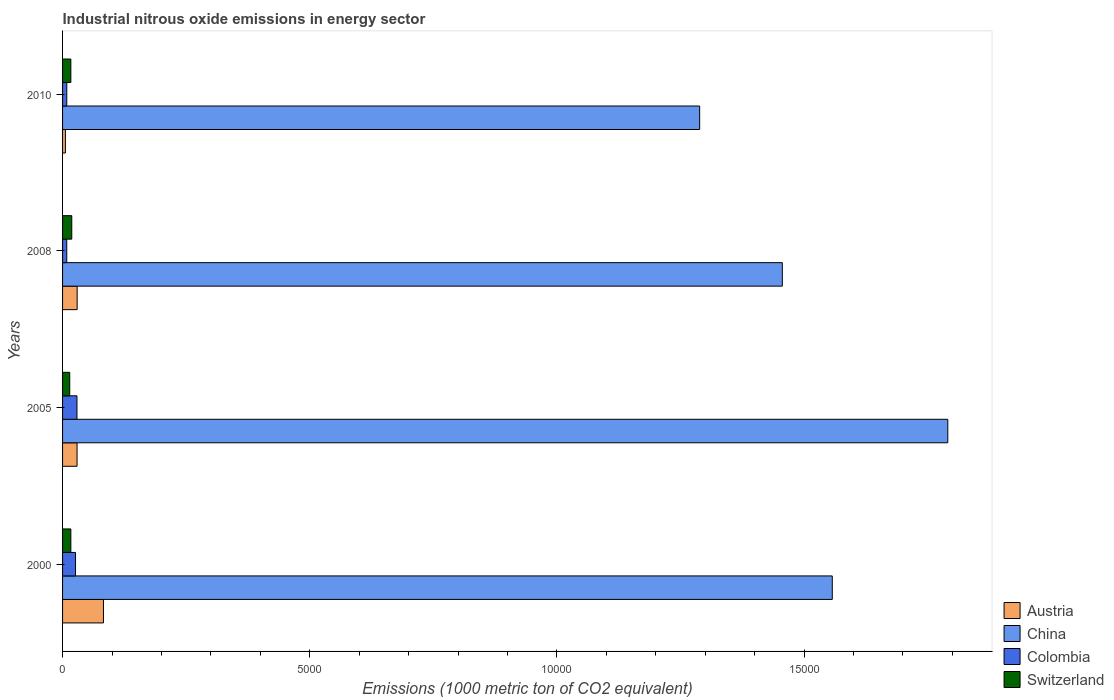How many different coloured bars are there?
Offer a terse response. 4. In how many cases, is the number of bars for a given year not equal to the number of legend labels?
Keep it short and to the point. 0. What is the amount of industrial nitrous oxide emitted in Colombia in 2008?
Your response must be concise. 84.7. Across all years, what is the maximum amount of industrial nitrous oxide emitted in Austria?
Provide a succinct answer. 827.2. Across all years, what is the minimum amount of industrial nitrous oxide emitted in China?
Offer a very short reply. 1.29e+04. In which year was the amount of industrial nitrous oxide emitted in China minimum?
Make the answer very short. 2010. What is the total amount of industrial nitrous oxide emitted in Austria in the graph?
Make the answer very short. 1473.2. What is the difference between the amount of industrial nitrous oxide emitted in China in 2000 and that in 2010?
Your answer should be very brief. 2682.7. What is the difference between the amount of industrial nitrous oxide emitted in Switzerland in 2005 and the amount of industrial nitrous oxide emitted in Colombia in 2000?
Your answer should be very brief. -117.2. What is the average amount of industrial nitrous oxide emitted in China per year?
Make the answer very short. 1.52e+04. In the year 2008, what is the difference between the amount of industrial nitrous oxide emitted in Austria and amount of industrial nitrous oxide emitted in China?
Your answer should be very brief. -1.43e+04. What is the ratio of the amount of industrial nitrous oxide emitted in China in 2000 to that in 2008?
Your answer should be compact. 1.07. Is the amount of industrial nitrous oxide emitted in Austria in 2005 less than that in 2008?
Your answer should be very brief. Yes. What is the difference between the highest and the second highest amount of industrial nitrous oxide emitted in Switzerland?
Your answer should be very brief. 18.6. What is the difference between the highest and the lowest amount of industrial nitrous oxide emitted in Austria?
Your answer should be very brief. 769.7. In how many years, is the amount of industrial nitrous oxide emitted in China greater than the average amount of industrial nitrous oxide emitted in China taken over all years?
Offer a terse response. 2. Is the sum of the amount of industrial nitrous oxide emitted in Colombia in 2005 and 2010 greater than the maximum amount of industrial nitrous oxide emitted in Austria across all years?
Provide a succinct answer. No. What does the 2nd bar from the top in 2010 represents?
Your answer should be very brief. Colombia. What does the 4th bar from the bottom in 2008 represents?
Provide a short and direct response. Switzerland. How many bars are there?
Your answer should be very brief. 16. Are all the bars in the graph horizontal?
Your answer should be compact. Yes. How many years are there in the graph?
Keep it short and to the point. 4. Does the graph contain grids?
Ensure brevity in your answer.  No. Where does the legend appear in the graph?
Provide a succinct answer. Bottom right. What is the title of the graph?
Your answer should be compact. Industrial nitrous oxide emissions in energy sector. Does "Middle East & North Africa (developing only)" appear as one of the legend labels in the graph?
Your answer should be very brief. No. What is the label or title of the X-axis?
Provide a short and direct response. Emissions (1000 metric ton of CO2 equivalent). What is the Emissions (1000 metric ton of CO2 equivalent) of Austria in 2000?
Your answer should be very brief. 827.2. What is the Emissions (1000 metric ton of CO2 equivalent) in China in 2000?
Offer a very short reply. 1.56e+04. What is the Emissions (1000 metric ton of CO2 equivalent) of Colombia in 2000?
Provide a short and direct response. 262.3. What is the Emissions (1000 metric ton of CO2 equivalent) in Switzerland in 2000?
Make the answer very short. 167.4. What is the Emissions (1000 metric ton of CO2 equivalent) of Austria in 2005?
Keep it short and to the point. 293.3. What is the Emissions (1000 metric ton of CO2 equivalent) in China in 2005?
Make the answer very short. 1.79e+04. What is the Emissions (1000 metric ton of CO2 equivalent) in Colombia in 2005?
Your response must be concise. 291.3. What is the Emissions (1000 metric ton of CO2 equivalent) of Switzerland in 2005?
Offer a very short reply. 145.1. What is the Emissions (1000 metric ton of CO2 equivalent) in Austria in 2008?
Offer a terse response. 295.2. What is the Emissions (1000 metric ton of CO2 equivalent) in China in 2008?
Keep it short and to the point. 1.46e+04. What is the Emissions (1000 metric ton of CO2 equivalent) in Colombia in 2008?
Your answer should be compact. 84.7. What is the Emissions (1000 metric ton of CO2 equivalent) in Switzerland in 2008?
Give a very brief answer. 186. What is the Emissions (1000 metric ton of CO2 equivalent) in Austria in 2010?
Offer a very short reply. 57.5. What is the Emissions (1000 metric ton of CO2 equivalent) of China in 2010?
Provide a short and direct response. 1.29e+04. What is the Emissions (1000 metric ton of CO2 equivalent) in Colombia in 2010?
Ensure brevity in your answer.  85.2. What is the Emissions (1000 metric ton of CO2 equivalent) in Switzerland in 2010?
Offer a terse response. 167.4. Across all years, what is the maximum Emissions (1000 metric ton of CO2 equivalent) in Austria?
Your answer should be compact. 827.2. Across all years, what is the maximum Emissions (1000 metric ton of CO2 equivalent) in China?
Offer a terse response. 1.79e+04. Across all years, what is the maximum Emissions (1000 metric ton of CO2 equivalent) of Colombia?
Give a very brief answer. 291.3. Across all years, what is the maximum Emissions (1000 metric ton of CO2 equivalent) in Switzerland?
Make the answer very short. 186. Across all years, what is the minimum Emissions (1000 metric ton of CO2 equivalent) of Austria?
Ensure brevity in your answer.  57.5. Across all years, what is the minimum Emissions (1000 metric ton of CO2 equivalent) of China?
Make the answer very short. 1.29e+04. Across all years, what is the minimum Emissions (1000 metric ton of CO2 equivalent) of Colombia?
Your answer should be compact. 84.7. Across all years, what is the minimum Emissions (1000 metric ton of CO2 equivalent) of Switzerland?
Make the answer very short. 145.1. What is the total Emissions (1000 metric ton of CO2 equivalent) of Austria in the graph?
Ensure brevity in your answer.  1473.2. What is the total Emissions (1000 metric ton of CO2 equivalent) of China in the graph?
Provide a short and direct response. 6.09e+04. What is the total Emissions (1000 metric ton of CO2 equivalent) in Colombia in the graph?
Make the answer very short. 723.5. What is the total Emissions (1000 metric ton of CO2 equivalent) of Switzerland in the graph?
Keep it short and to the point. 665.9. What is the difference between the Emissions (1000 metric ton of CO2 equivalent) in Austria in 2000 and that in 2005?
Offer a very short reply. 533.9. What is the difference between the Emissions (1000 metric ton of CO2 equivalent) of China in 2000 and that in 2005?
Offer a very short reply. -2336.7. What is the difference between the Emissions (1000 metric ton of CO2 equivalent) of Switzerland in 2000 and that in 2005?
Offer a very short reply. 22.3. What is the difference between the Emissions (1000 metric ton of CO2 equivalent) in Austria in 2000 and that in 2008?
Keep it short and to the point. 532. What is the difference between the Emissions (1000 metric ton of CO2 equivalent) in China in 2000 and that in 2008?
Your response must be concise. 1010.8. What is the difference between the Emissions (1000 metric ton of CO2 equivalent) of Colombia in 2000 and that in 2008?
Keep it short and to the point. 177.6. What is the difference between the Emissions (1000 metric ton of CO2 equivalent) of Switzerland in 2000 and that in 2008?
Your answer should be compact. -18.6. What is the difference between the Emissions (1000 metric ton of CO2 equivalent) of Austria in 2000 and that in 2010?
Give a very brief answer. 769.7. What is the difference between the Emissions (1000 metric ton of CO2 equivalent) of China in 2000 and that in 2010?
Make the answer very short. 2682.7. What is the difference between the Emissions (1000 metric ton of CO2 equivalent) of Colombia in 2000 and that in 2010?
Make the answer very short. 177.1. What is the difference between the Emissions (1000 metric ton of CO2 equivalent) in Austria in 2005 and that in 2008?
Your answer should be very brief. -1.9. What is the difference between the Emissions (1000 metric ton of CO2 equivalent) in China in 2005 and that in 2008?
Make the answer very short. 3347.5. What is the difference between the Emissions (1000 metric ton of CO2 equivalent) of Colombia in 2005 and that in 2008?
Keep it short and to the point. 206.6. What is the difference between the Emissions (1000 metric ton of CO2 equivalent) in Switzerland in 2005 and that in 2008?
Your response must be concise. -40.9. What is the difference between the Emissions (1000 metric ton of CO2 equivalent) of Austria in 2005 and that in 2010?
Give a very brief answer. 235.8. What is the difference between the Emissions (1000 metric ton of CO2 equivalent) of China in 2005 and that in 2010?
Offer a terse response. 5019.4. What is the difference between the Emissions (1000 metric ton of CO2 equivalent) of Colombia in 2005 and that in 2010?
Offer a terse response. 206.1. What is the difference between the Emissions (1000 metric ton of CO2 equivalent) in Switzerland in 2005 and that in 2010?
Make the answer very short. -22.3. What is the difference between the Emissions (1000 metric ton of CO2 equivalent) in Austria in 2008 and that in 2010?
Your response must be concise. 237.7. What is the difference between the Emissions (1000 metric ton of CO2 equivalent) in China in 2008 and that in 2010?
Offer a terse response. 1671.9. What is the difference between the Emissions (1000 metric ton of CO2 equivalent) in Colombia in 2008 and that in 2010?
Your response must be concise. -0.5. What is the difference between the Emissions (1000 metric ton of CO2 equivalent) of Austria in 2000 and the Emissions (1000 metric ton of CO2 equivalent) of China in 2005?
Give a very brief answer. -1.71e+04. What is the difference between the Emissions (1000 metric ton of CO2 equivalent) of Austria in 2000 and the Emissions (1000 metric ton of CO2 equivalent) of Colombia in 2005?
Your answer should be compact. 535.9. What is the difference between the Emissions (1000 metric ton of CO2 equivalent) in Austria in 2000 and the Emissions (1000 metric ton of CO2 equivalent) in Switzerland in 2005?
Your answer should be compact. 682.1. What is the difference between the Emissions (1000 metric ton of CO2 equivalent) of China in 2000 and the Emissions (1000 metric ton of CO2 equivalent) of Colombia in 2005?
Ensure brevity in your answer.  1.53e+04. What is the difference between the Emissions (1000 metric ton of CO2 equivalent) of China in 2000 and the Emissions (1000 metric ton of CO2 equivalent) of Switzerland in 2005?
Provide a short and direct response. 1.54e+04. What is the difference between the Emissions (1000 metric ton of CO2 equivalent) in Colombia in 2000 and the Emissions (1000 metric ton of CO2 equivalent) in Switzerland in 2005?
Give a very brief answer. 117.2. What is the difference between the Emissions (1000 metric ton of CO2 equivalent) in Austria in 2000 and the Emissions (1000 metric ton of CO2 equivalent) in China in 2008?
Your answer should be very brief. -1.37e+04. What is the difference between the Emissions (1000 metric ton of CO2 equivalent) of Austria in 2000 and the Emissions (1000 metric ton of CO2 equivalent) of Colombia in 2008?
Provide a short and direct response. 742.5. What is the difference between the Emissions (1000 metric ton of CO2 equivalent) of Austria in 2000 and the Emissions (1000 metric ton of CO2 equivalent) of Switzerland in 2008?
Your response must be concise. 641.2. What is the difference between the Emissions (1000 metric ton of CO2 equivalent) of China in 2000 and the Emissions (1000 metric ton of CO2 equivalent) of Colombia in 2008?
Give a very brief answer. 1.55e+04. What is the difference between the Emissions (1000 metric ton of CO2 equivalent) in China in 2000 and the Emissions (1000 metric ton of CO2 equivalent) in Switzerland in 2008?
Your response must be concise. 1.54e+04. What is the difference between the Emissions (1000 metric ton of CO2 equivalent) in Colombia in 2000 and the Emissions (1000 metric ton of CO2 equivalent) in Switzerland in 2008?
Ensure brevity in your answer.  76.3. What is the difference between the Emissions (1000 metric ton of CO2 equivalent) of Austria in 2000 and the Emissions (1000 metric ton of CO2 equivalent) of China in 2010?
Provide a short and direct response. -1.21e+04. What is the difference between the Emissions (1000 metric ton of CO2 equivalent) in Austria in 2000 and the Emissions (1000 metric ton of CO2 equivalent) in Colombia in 2010?
Your answer should be compact. 742. What is the difference between the Emissions (1000 metric ton of CO2 equivalent) of Austria in 2000 and the Emissions (1000 metric ton of CO2 equivalent) of Switzerland in 2010?
Your answer should be compact. 659.8. What is the difference between the Emissions (1000 metric ton of CO2 equivalent) of China in 2000 and the Emissions (1000 metric ton of CO2 equivalent) of Colombia in 2010?
Offer a terse response. 1.55e+04. What is the difference between the Emissions (1000 metric ton of CO2 equivalent) of China in 2000 and the Emissions (1000 metric ton of CO2 equivalent) of Switzerland in 2010?
Your answer should be compact. 1.54e+04. What is the difference between the Emissions (1000 metric ton of CO2 equivalent) in Colombia in 2000 and the Emissions (1000 metric ton of CO2 equivalent) in Switzerland in 2010?
Provide a short and direct response. 94.9. What is the difference between the Emissions (1000 metric ton of CO2 equivalent) of Austria in 2005 and the Emissions (1000 metric ton of CO2 equivalent) of China in 2008?
Keep it short and to the point. -1.43e+04. What is the difference between the Emissions (1000 metric ton of CO2 equivalent) in Austria in 2005 and the Emissions (1000 metric ton of CO2 equivalent) in Colombia in 2008?
Keep it short and to the point. 208.6. What is the difference between the Emissions (1000 metric ton of CO2 equivalent) of Austria in 2005 and the Emissions (1000 metric ton of CO2 equivalent) of Switzerland in 2008?
Your answer should be compact. 107.3. What is the difference between the Emissions (1000 metric ton of CO2 equivalent) of China in 2005 and the Emissions (1000 metric ton of CO2 equivalent) of Colombia in 2008?
Offer a terse response. 1.78e+04. What is the difference between the Emissions (1000 metric ton of CO2 equivalent) in China in 2005 and the Emissions (1000 metric ton of CO2 equivalent) in Switzerland in 2008?
Ensure brevity in your answer.  1.77e+04. What is the difference between the Emissions (1000 metric ton of CO2 equivalent) of Colombia in 2005 and the Emissions (1000 metric ton of CO2 equivalent) of Switzerland in 2008?
Give a very brief answer. 105.3. What is the difference between the Emissions (1000 metric ton of CO2 equivalent) of Austria in 2005 and the Emissions (1000 metric ton of CO2 equivalent) of China in 2010?
Your answer should be compact. -1.26e+04. What is the difference between the Emissions (1000 metric ton of CO2 equivalent) of Austria in 2005 and the Emissions (1000 metric ton of CO2 equivalent) of Colombia in 2010?
Keep it short and to the point. 208.1. What is the difference between the Emissions (1000 metric ton of CO2 equivalent) of Austria in 2005 and the Emissions (1000 metric ton of CO2 equivalent) of Switzerland in 2010?
Make the answer very short. 125.9. What is the difference between the Emissions (1000 metric ton of CO2 equivalent) of China in 2005 and the Emissions (1000 metric ton of CO2 equivalent) of Colombia in 2010?
Give a very brief answer. 1.78e+04. What is the difference between the Emissions (1000 metric ton of CO2 equivalent) of China in 2005 and the Emissions (1000 metric ton of CO2 equivalent) of Switzerland in 2010?
Ensure brevity in your answer.  1.77e+04. What is the difference between the Emissions (1000 metric ton of CO2 equivalent) of Colombia in 2005 and the Emissions (1000 metric ton of CO2 equivalent) of Switzerland in 2010?
Ensure brevity in your answer.  123.9. What is the difference between the Emissions (1000 metric ton of CO2 equivalent) of Austria in 2008 and the Emissions (1000 metric ton of CO2 equivalent) of China in 2010?
Provide a succinct answer. -1.26e+04. What is the difference between the Emissions (1000 metric ton of CO2 equivalent) in Austria in 2008 and the Emissions (1000 metric ton of CO2 equivalent) in Colombia in 2010?
Give a very brief answer. 210. What is the difference between the Emissions (1000 metric ton of CO2 equivalent) of Austria in 2008 and the Emissions (1000 metric ton of CO2 equivalent) of Switzerland in 2010?
Provide a succinct answer. 127.8. What is the difference between the Emissions (1000 metric ton of CO2 equivalent) in China in 2008 and the Emissions (1000 metric ton of CO2 equivalent) in Colombia in 2010?
Offer a terse response. 1.45e+04. What is the difference between the Emissions (1000 metric ton of CO2 equivalent) in China in 2008 and the Emissions (1000 metric ton of CO2 equivalent) in Switzerland in 2010?
Your answer should be very brief. 1.44e+04. What is the difference between the Emissions (1000 metric ton of CO2 equivalent) of Colombia in 2008 and the Emissions (1000 metric ton of CO2 equivalent) of Switzerland in 2010?
Ensure brevity in your answer.  -82.7. What is the average Emissions (1000 metric ton of CO2 equivalent) in Austria per year?
Your response must be concise. 368.3. What is the average Emissions (1000 metric ton of CO2 equivalent) of China per year?
Keep it short and to the point. 1.52e+04. What is the average Emissions (1000 metric ton of CO2 equivalent) of Colombia per year?
Give a very brief answer. 180.88. What is the average Emissions (1000 metric ton of CO2 equivalent) in Switzerland per year?
Provide a succinct answer. 166.47. In the year 2000, what is the difference between the Emissions (1000 metric ton of CO2 equivalent) of Austria and Emissions (1000 metric ton of CO2 equivalent) of China?
Ensure brevity in your answer.  -1.47e+04. In the year 2000, what is the difference between the Emissions (1000 metric ton of CO2 equivalent) of Austria and Emissions (1000 metric ton of CO2 equivalent) of Colombia?
Your answer should be compact. 564.9. In the year 2000, what is the difference between the Emissions (1000 metric ton of CO2 equivalent) in Austria and Emissions (1000 metric ton of CO2 equivalent) in Switzerland?
Offer a terse response. 659.8. In the year 2000, what is the difference between the Emissions (1000 metric ton of CO2 equivalent) of China and Emissions (1000 metric ton of CO2 equivalent) of Colombia?
Give a very brief answer. 1.53e+04. In the year 2000, what is the difference between the Emissions (1000 metric ton of CO2 equivalent) in China and Emissions (1000 metric ton of CO2 equivalent) in Switzerland?
Give a very brief answer. 1.54e+04. In the year 2000, what is the difference between the Emissions (1000 metric ton of CO2 equivalent) of Colombia and Emissions (1000 metric ton of CO2 equivalent) of Switzerland?
Give a very brief answer. 94.9. In the year 2005, what is the difference between the Emissions (1000 metric ton of CO2 equivalent) in Austria and Emissions (1000 metric ton of CO2 equivalent) in China?
Offer a very short reply. -1.76e+04. In the year 2005, what is the difference between the Emissions (1000 metric ton of CO2 equivalent) of Austria and Emissions (1000 metric ton of CO2 equivalent) of Colombia?
Provide a succinct answer. 2. In the year 2005, what is the difference between the Emissions (1000 metric ton of CO2 equivalent) of Austria and Emissions (1000 metric ton of CO2 equivalent) of Switzerland?
Ensure brevity in your answer.  148.2. In the year 2005, what is the difference between the Emissions (1000 metric ton of CO2 equivalent) in China and Emissions (1000 metric ton of CO2 equivalent) in Colombia?
Offer a terse response. 1.76e+04. In the year 2005, what is the difference between the Emissions (1000 metric ton of CO2 equivalent) in China and Emissions (1000 metric ton of CO2 equivalent) in Switzerland?
Offer a very short reply. 1.78e+04. In the year 2005, what is the difference between the Emissions (1000 metric ton of CO2 equivalent) in Colombia and Emissions (1000 metric ton of CO2 equivalent) in Switzerland?
Keep it short and to the point. 146.2. In the year 2008, what is the difference between the Emissions (1000 metric ton of CO2 equivalent) of Austria and Emissions (1000 metric ton of CO2 equivalent) of China?
Keep it short and to the point. -1.43e+04. In the year 2008, what is the difference between the Emissions (1000 metric ton of CO2 equivalent) of Austria and Emissions (1000 metric ton of CO2 equivalent) of Colombia?
Keep it short and to the point. 210.5. In the year 2008, what is the difference between the Emissions (1000 metric ton of CO2 equivalent) of Austria and Emissions (1000 metric ton of CO2 equivalent) of Switzerland?
Offer a terse response. 109.2. In the year 2008, what is the difference between the Emissions (1000 metric ton of CO2 equivalent) of China and Emissions (1000 metric ton of CO2 equivalent) of Colombia?
Make the answer very short. 1.45e+04. In the year 2008, what is the difference between the Emissions (1000 metric ton of CO2 equivalent) of China and Emissions (1000 metric ton of CO2 equivalent) of Switzerland?
Keep it short and to the point. 1.44e+04. In the year 2008, what is the difference between the Emissions (1000 metric ton of CO2 equivalent) in Colombia and Emissions (1000 metric ton of CO2 equivalent) in Switzerland?
Provide a short and direct response. -101.3. In the year 2010, what is the difference between the Emissions (1000 metric ton of CO2 equivalent) of Austria and Emissions (1000 metric ton of CO2 equivalent) of China?
Ensure brevity in your answer.  -1.28e+04. In the year 2010, what is the difference between the Emissions (1000 metric ton of CO2 equivalent) in Austria and Emissions (1000 metric ton of CO2 equivalent) in Colombia?
Offer a very short reply. -27.7. In the year 2010, what is the difference between the Emissions (1000 metric ton of CO2 equivalent) in Austria and Emissions (1000 metric ton of CO2 equivalent) in Switzerland?
Keep it short and to the point. -109.9. In the year 2010, what is the difference between the Emissions (1000 metric ton of CO2 equivalent) in China and Emissions (1000 metric ton of CO2 equivalent) in Colombia?
Give a very brief answer. 1.28e+04. In the year 2010, what is the difference between the Emissions (1000 metric ton of CO2 equivalent) in China and Emissions (1000 metric ton of CO2 equivalent) in Switzerland?
Your answer should be very brief. 1.27e+04. In the year 2010, what is the difference between the Emissions (1000 metric ton of CO2 equivalent) of Colombia and Emissions (1000 metric ton of CO2 equivalent) of Switzerland?
Your answer should be very brief. -82.2. What is the ratio of the Emissions (1000 metric ton of CO2 equivalent) of Austria in 2000 to that in 2005?
Offer a terse response. 2.82. What is the ratio of the Emissions (1000 metric ton of CO2 equivalent) of China in 2000 to that in 2005?
Offer a terse response. 0.87. What is the ratio of the Emissions (1000 metric ton of CO2 equivalent) of Colombia in 2000 to that in 2005?
Your answer should be very brief. 0.9. What is the ratio of the Emissions (1000 metric ton of CO2 equivalent) of Switzerland in 2000 to that in 2005?
Keep it short and to the point. 1.15. What is the ratio of the Emissions (1000 metric ton of CO2 equivalent) in Austria in 2000 to that in 2008?
Provide a succinct answer. 2.8. What is the ratio of the Emissions (1000 metric ton of CO2 equivalent) of China in 2000 to that in 2008?
Give a very brief answer. 1.07. What is the ratio of the Emissions (1000 metric ton of CO2 equivalent) of Colombia in 2000 to that in 2008?
Make the answer very short. 3.1. What is the ratio of the Emissions (1000 metric ton of CO2 equivalent) in Switzerland in 2000 to that in 2008?
Your answer should be very brief. 0.9. What is the ratio of the Emissions (1000 metric ton of CO2 equivalent) of Austria in 2000 to that in 2010?
Your answer should be very brief. 14.39. What is the ratio of the Emissions (1000 metric ton of CO2 equivalent) in China in 2000 to that in 2010?
Your response must be concise. 1.21. What is the ratio of the Emissions (1000 metric ton of CO2 equivalent) in Colombia in 2000 to that in 2010?
Offer a very short reply. 3.08. What is the ratio of the Emissions (1000 metric ton of CO2 equivalent) of China in 2005 to that in 2008?
Ensure brevity in your answer.  1.23. What is the ratio of the Emissions (1000 metric ton of CO2 equivalent) of Colombia in 2005 to that in 2008?
Your response must be concise. 3.44. What is the ratio of the Emissions (1000 metric ton of CO2 equivalent) in Switzerland in 2005 to that in 2008?
Your answer should be very brief. 0.78. What is the ratio of the Emissions (1000 metric ton of CO2 equivalent) of Austria in 2005 to that in 2010?
Ensure brevity in your answer.  5.1. What is the ratio of the Emissions (1000 metric ton of CO2 equivalent) in China in 2005 to that in 2010?
Give a very brief answer. 1.39. What is the ratio of the Emissions (1000 metric ton of CO2 equivalent) in Colombia in 2005 to that in 2010?
Provide a succinct answer. 3.42. What is the ratio of the Emissions (1000 metric ton of CO2 equivalent) of Switzerland in 2005 to that in 2010?
Offer a terse response. 0.87. What is the ratio of the Emissions (1000 metric ton of CO2 equivalent) in Austria in 2008 to that in 2010?
Offer a terse response. 5.13. What is the ratio of the Emissions (1000 metric ton of CO2 equivalent) of China in 2008 to that in 2010?
Your answer should be very brief. 1.13. What is the ratio of the Emissions (1000 metric ton of CO2 equivalent) in Switzerland in 2008 to that in 2010?
Your answer should be compact. 1.11. What is the difference between the highest and the second highest Emissions (1000 metric ton of CO2 equivalent) in Austria?
Provide a short and direct response. 532. What is the difference between the highest and the second highest Emissions (1000 metric ton of CO2 equivalent) in China?
Make the answer very short. 2336.7. What is the difference between the highest and the second highest Emissions (1000 metric ton of CO2 equivalent) of Switzerland?
Your answer should be very brief. 18.6. What is the difference between the highest and the lowest Emissions (1000 metric ton of CO2 equivalent) in Austria?
Make the answer very short. 769.7. What is the difference between the highest and the lowest Emissions (1000 metric ton of CO2 equivalent) in China?
Give a very brief answer. 5019.4. What is the difference between the highest and the lowest Emissions (1000 metric ton of CO2 equivalent) in Colombia?
Ensure brevity in your answer.  206.6. What is the difference between the highest and the lowest Emissions (1000 metric ton of CO2 equivalent) in Switzerland?
Your response must be concise. 40.9. 